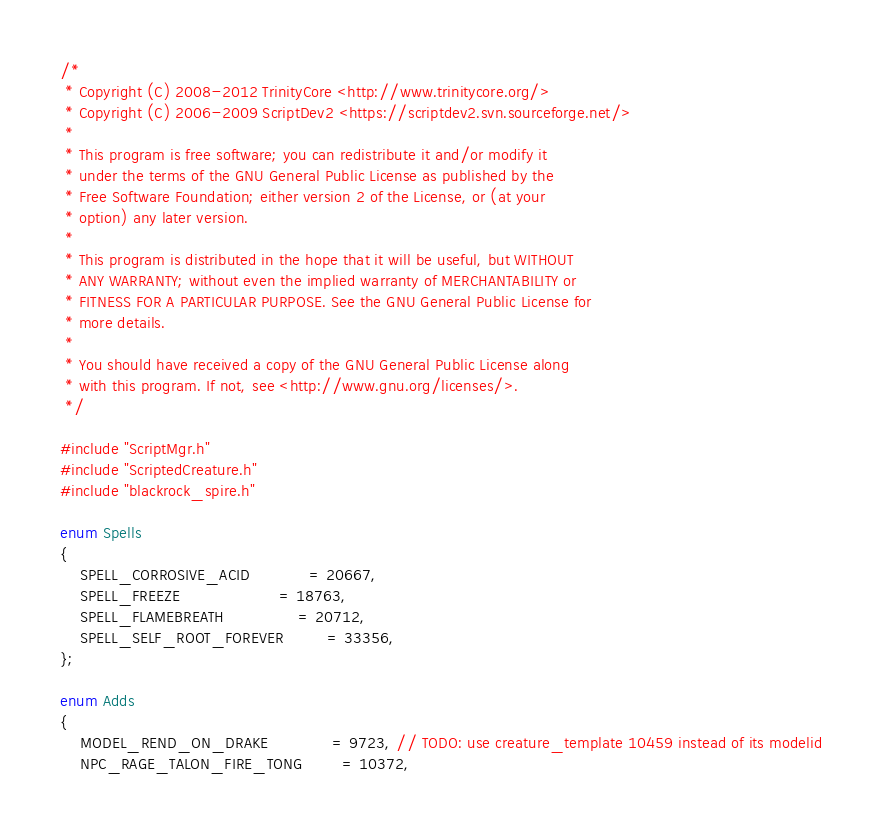Convert code to text. <code><loc_0><loc_0><loc_500><loc_500><_C++_>/*
 * Copyright (C) 2008-2012 TrinityCore <http://www.trinitycore.org/>
 * Copyright (C) 2006-2009 ScriptDev2 <https://scriptdev2.svn.sourceforge.net/>
 *
 * This program is free software; you can redistribute it and/or modify it
 * under the terms of the GNU General Public License as published by the
 * Free Software Foundation; either version 2 of the License, or (at your
 * option) any later version.
 *
 * This program is distributed in the hope that it will be useful, but WITHOUT
 * ANY WARRANTY; without even the implied warranty of MERCHANTABILITY or
 * FITNESS FOR A PARTICULAR PURPOSE. See the GNU General Public License for
 * more details.
 *
 * You should have received a copy of the GNU General Public License along
 * with this program. If not, see <http://www.gnu.org/licenses/>.
 */

#include "ScriptMgr.h"
#include "ScriptedCreature.h"
#include "blackrock_spire.h"

enum Spells
{
    SPELL_CORROSIVE_ACID            = 20667,
    SPELL_FREEZE                    = 18763,
    SPELL_FLAMEBREATH               = 20712,
    SPELL_SELF_ROOT_FOREVER         = 33356,
};

enum Adds
{
    MODEL_REND_ON_DRAKE             = 9723, // TODO: use creature_template 10459 instead of its modelid
    NPC_RAGE_TALON_FIRE_TONG        = 10372,</code> 